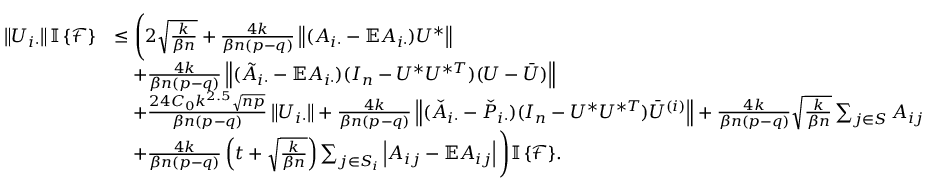<formula> <loc_0><loc_0><loc_500><loc_500>\begin{array} { r l } { \left \| { U _ { i \cdot } } \right \| { \mathbb { I } \left \{ { \mathcal { F } } \right \} } } & { \leq \left ( 2 \sqrt { \frac { k } { \beta n } } + \frac { 4 k } { \beta n ( p - q ) } \left \| { ( A _ { i \cdot } - \mathbb { E } A _ { i \cdot } ) U ^ { * } } \right \| } \\ & { \quad + \frac { 4 k } { \beta n ( p - q ) } \left \| { ( \tilde { A } _ { i \cdot } - \mathbb { E } A _ { i \cdot } ) ( I _ { n } - U ^ { * } U ^ { * T } ) ( U - \bar { U } ) } \right \| } \\ & { \quad + \frac { 2 4 C _ { 0 } k ^ { 2 . 5 } \sqrt { n p } } { \beta n ( p - q ) } \left \| { U _ { i \cdot } } \right \| + \frac { 4 k } { \beta n ( p - q ) } \left \| { ( \check { A } _ { i \cdot } - \check { P } _ { i \cdot } ) ( I _ { n } - U ^ { * } U ^ { * T } ) \bar { U } ^ { ( i ) } } \right \| + \frac { 4 k } { \beta n ( p - q ) } \sqrt { \frac { k } { \beta n } } \sum _ { j \in S } A _ { i j } } \\ & { \quad + \frac { 4 k } { \beta n ( p - q ) } \left ( t + \sqrt { \frac { k } { \beta n } } \right ) \sum _ { j \in S _ { i } } \left | A _ { i j } - \mathbb { E } A _ { i j } \right | \right ) { \mathbb { I } \left \{ { \mathcal { F } } \right \} } . } \end{array}</formula> 